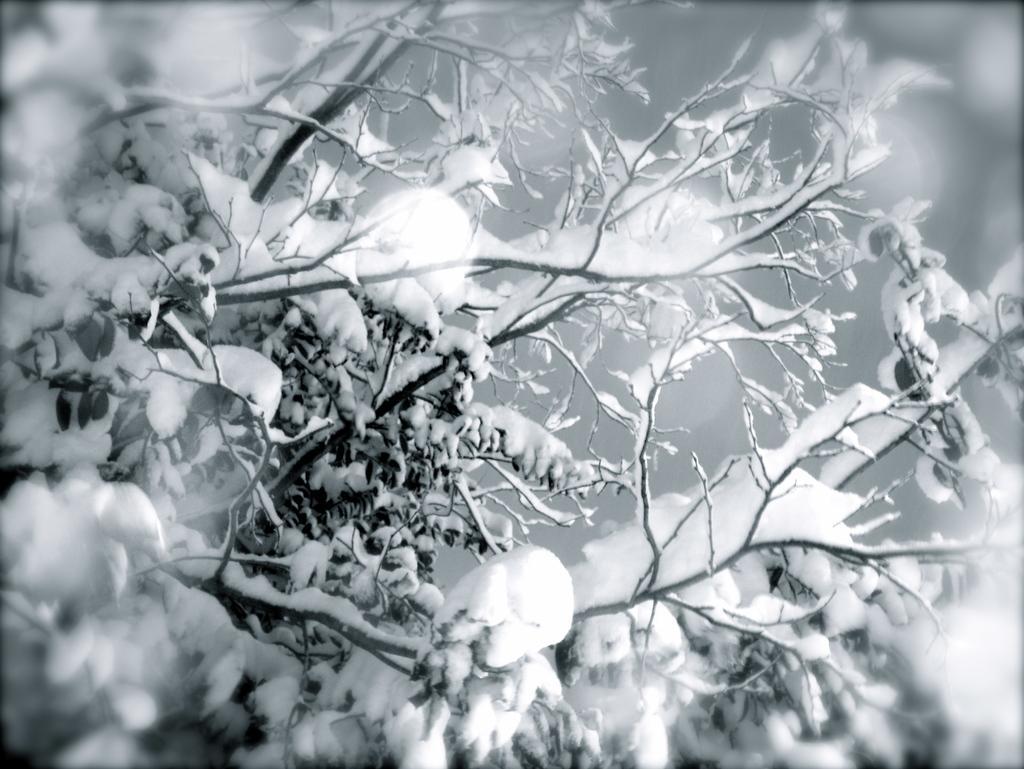Describe this image in one or two sentences. In this image there is a snow on the tree. 